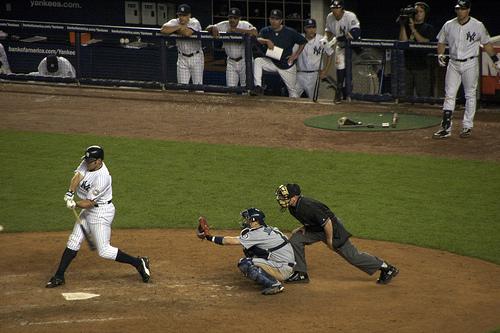Who is holding the bat?
Quick response, please. Batter. What number Jersey is the sitting person on the left wearing?
Keep it brief. 12. What is the bending man getting ready to do?
Give a very brief answer. Catch ball. What color is the batter's hat?
Be succinct. Black. Did the battery already hit the ball?
Short answer required. No. What number is the shirt on the man on deck?
Answer briefly. 14. What baseball team are the players from?
Write a very short answer. Yankees. Did the players just win the match?
Short answer required. No. Has the catcher caught the ball yet?
Short answer required. No. Is this a professional game?
Quick response, please. Yes. 